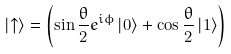Convert formula to latex. <formula><loc_0><loc_0><loc_500><loc_500>\left | \uparrow \right \rangle = \left ( \sin \frac { \theta } { 2 } e ^ { i \phi } \left | 0 \right \rangle + \cos \frac { \theta } { 2 } \left | 1 \right \rangle \right )</formula> 